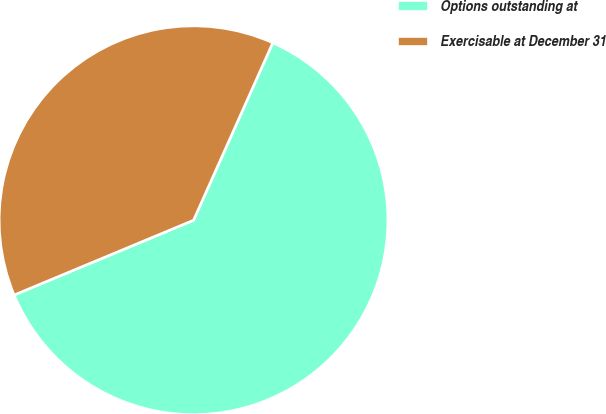<chart> <loc_0><loc_0><loc_500><loc_500><pie_chart><fcel>Options outstanding at<fcel>Exercisable at December 31<nl><fcel>62.03%<fcel>37.97%<nl></chart> 